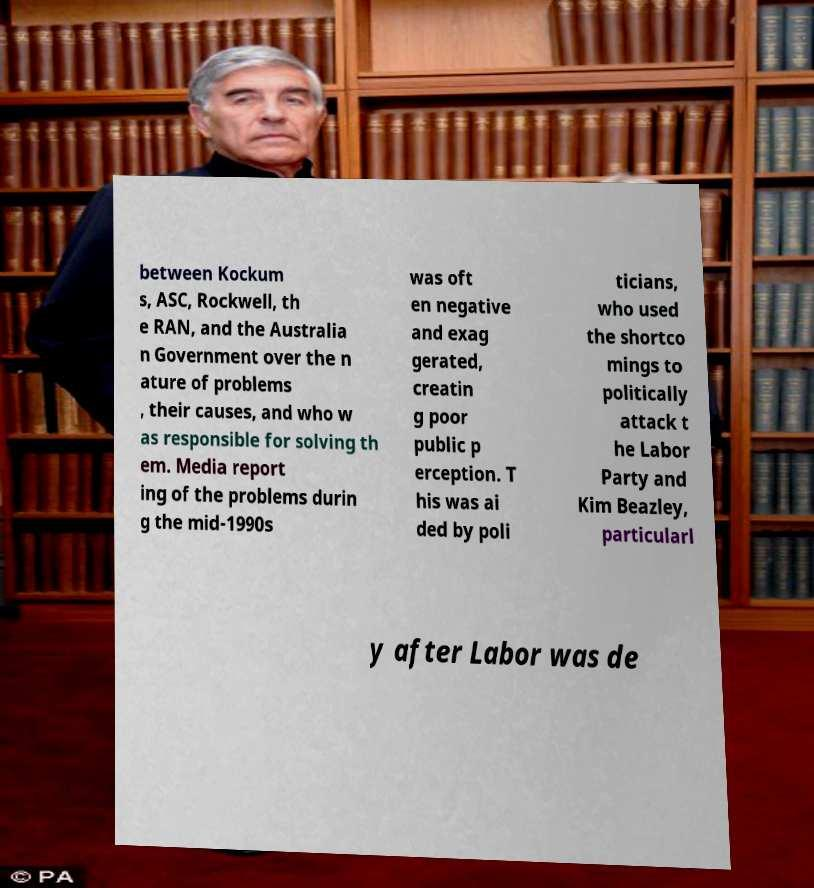Could you assist in decoding the text presented in this image and type it out clearly? between Kockum s, ASC, Rockwell, th e RAN, and the Australia n Government over the n ature of problems , their causes, and who w as responsible for solving th em. Media report ing of the problems durin g the mid-1990s was oft en negative and exag gerated, creatin g poor public p erception. T his was ai ded by poli ticians, who used the shortco mings to politically attack t he Labor Party and Kim Beazley, particularl y after Labor was de 